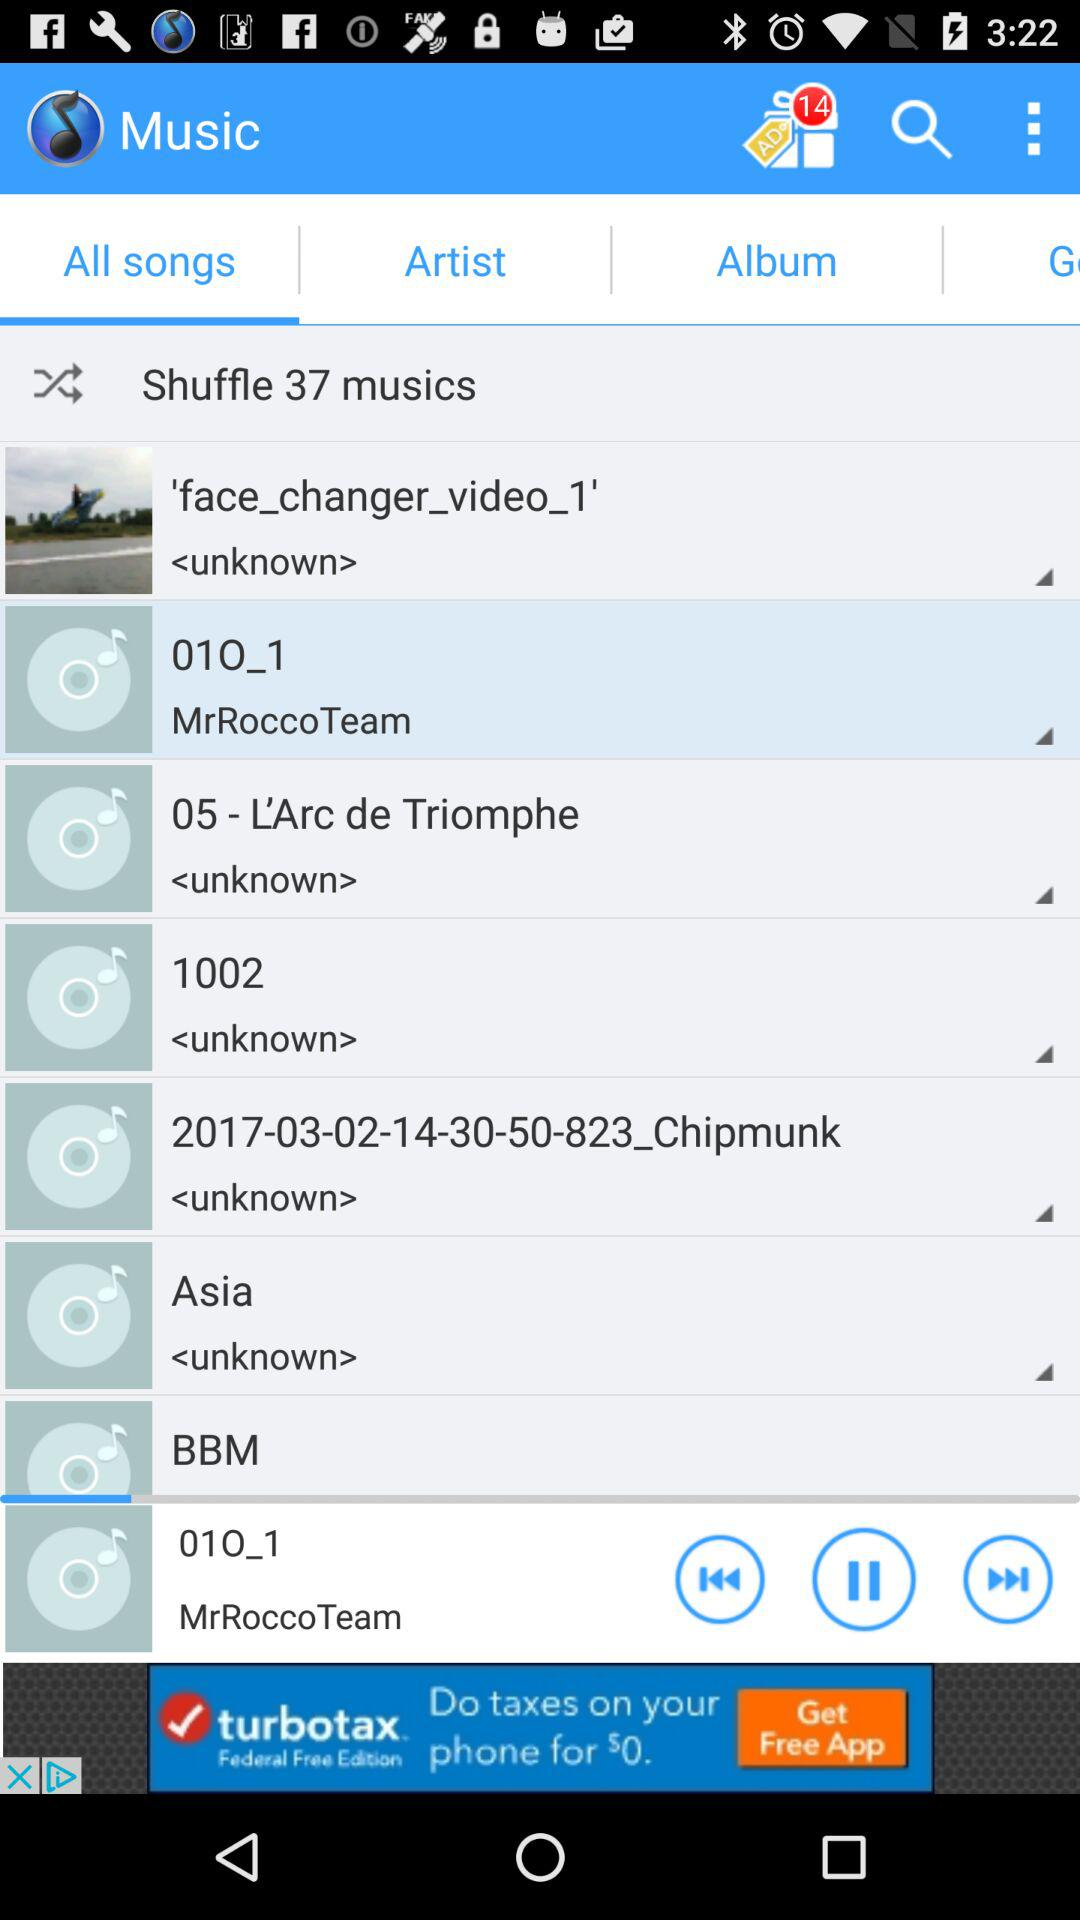What song is currently playing? The currently playing song is "01O_1". 